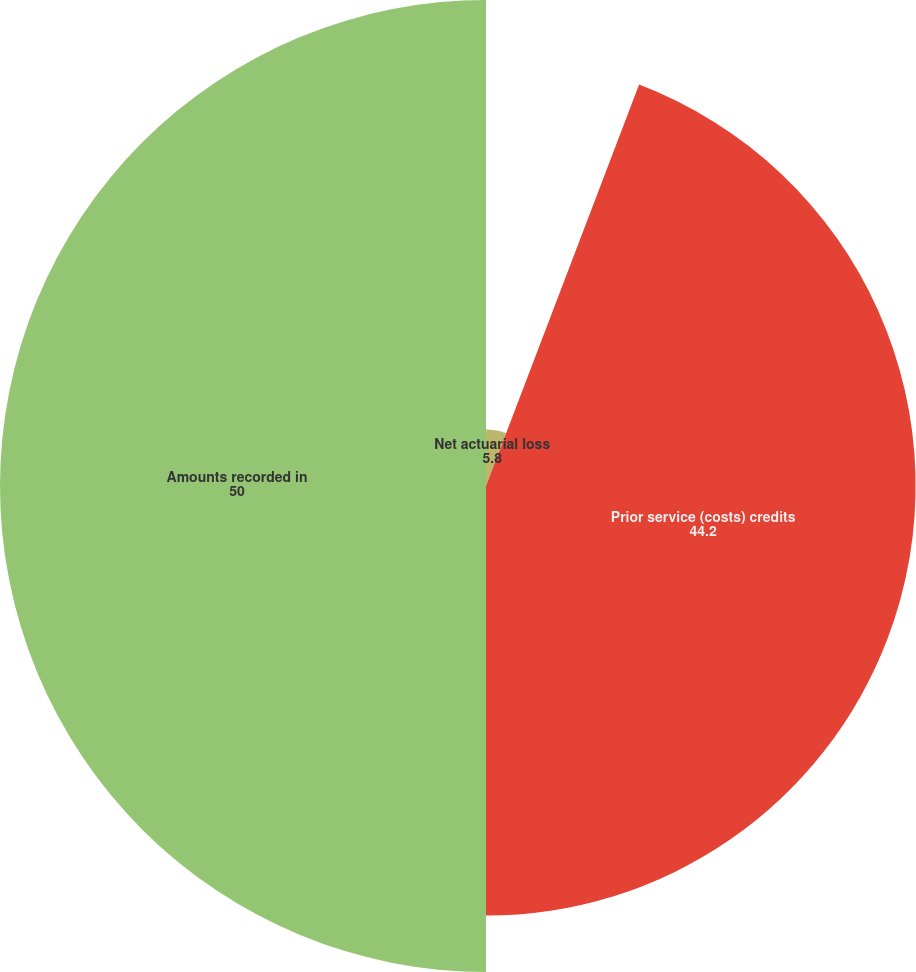<chart> <loc_0><loc_0><loc_500><loc_500><pie_chart><fcel>Net actuarial loss<fcel>Prior service (costs) credits<fcel>Amounts recorded in<nl><fcel>5.8%<fcel>44.2%<fcel>50.0%<nl></chart> 